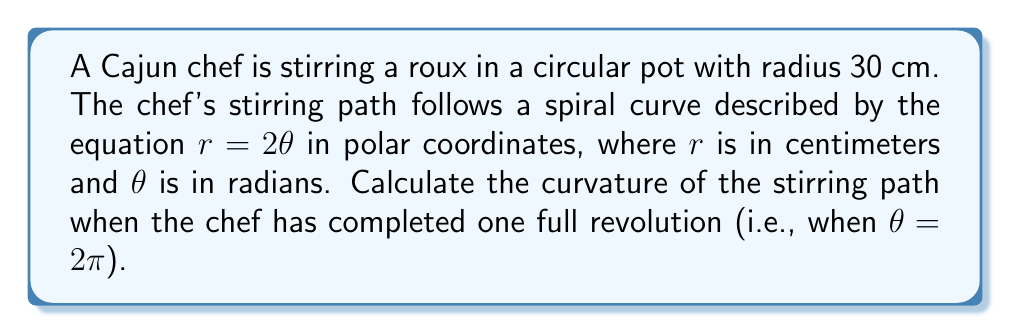Could you help me with this problem? To find the curvature of the stirring path, we'll follow these steps:

1) The curvature $\kappa$ of a curve in polar coordinates is given by:

   $$\kappa = \frac{|r^2 + 2(r')^2 - rr''|}{(r^2 + (r')^2)^{3/2}}$$

   where $r'$ and $r''$ are the first and second derivatives of $r$ with respect to $\theta$.

2) Given equation: $r = 2\theta$

3) Calculate $r'$ and $r''$:
   $r' = \frac{dr}{d\theta} = 2$
   $r'' = \frac{d^2r}{d\theta^2} = 0$

4) Substitute into the curvature formula:

   $$\kappa = \frac{|(2\theta)^2 + 2(2)^2 - 2\theta(0)|}{((2\theta)^2 + (2)^2)^{3/2}}$$

5) Simplify:

   $$\kappa = \frac{4\theta^2 + 8}{(4\theta^2 + 4)^{3/2}}$$

6) At one full revolution, $\theta = 2\pi$. Substitute this:

   $$\kappa = \frac{4(2\pi)^2 + 8}{(4(2\pi)^2 + 4)^{3/2}}$$

7) Calculate:

   $$\kappa = \frac{16\pi^2 + 8}{(16\pi^2 + 4)^{3/2}} \approx 0.0398 \text{ cm}^{-1}$$
Answer: $\frac{16\pi^2 + 8}{(16\pi^2 + 4)^{3/2}} \approx 0.0398 \text{ cm}^{-1}$ 